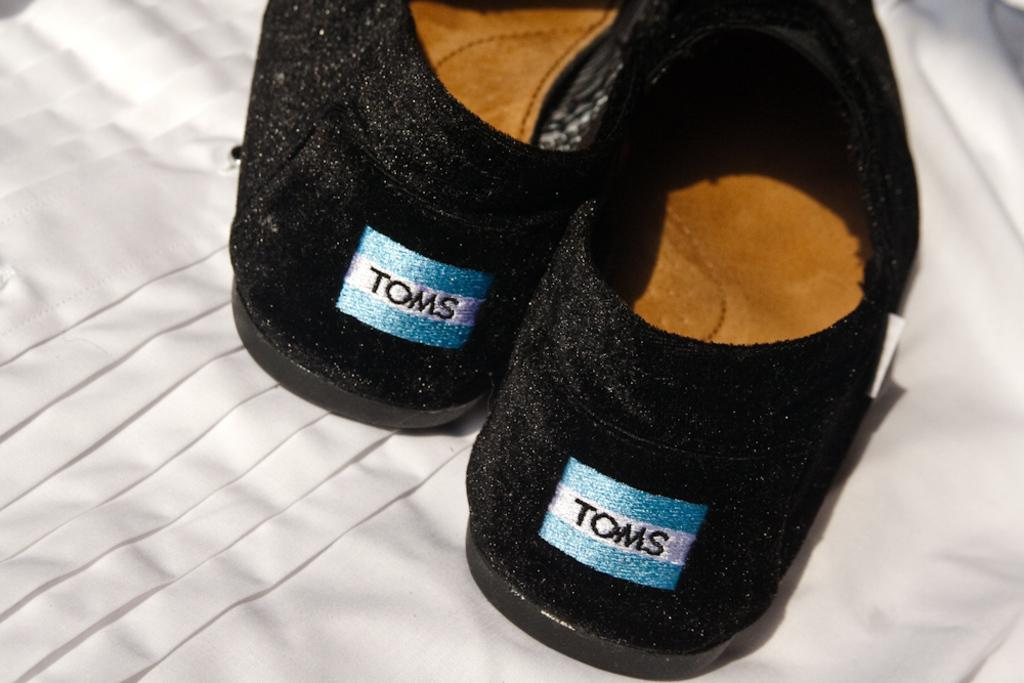What color is the cloth that is visible in the image? The cloth in the image is white. What type of footwear can be seen in the image? There are black color shoes in the image. How many members are in the committee that is present in the image? There is no committee present in the image; it only features a white cloth and black shoes. What type of animal can be seen interacting with the shoes in the image? There is no animal, such as a squirrel, present in the image; it only features a white cloth and black shoes. 